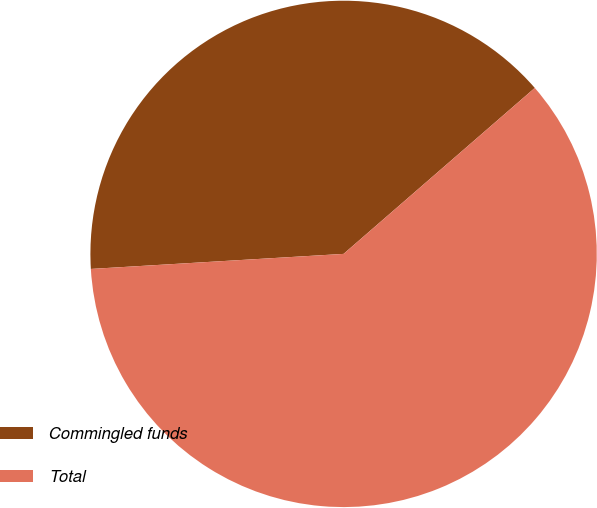Convert chart. <chart><loc_0><loc_0><loc_500><loc_500><pie_chart><fcel>Commingled funds<fcel>Total<nl><fcel>39.57%<fcel>60.43%<nl></chart> 